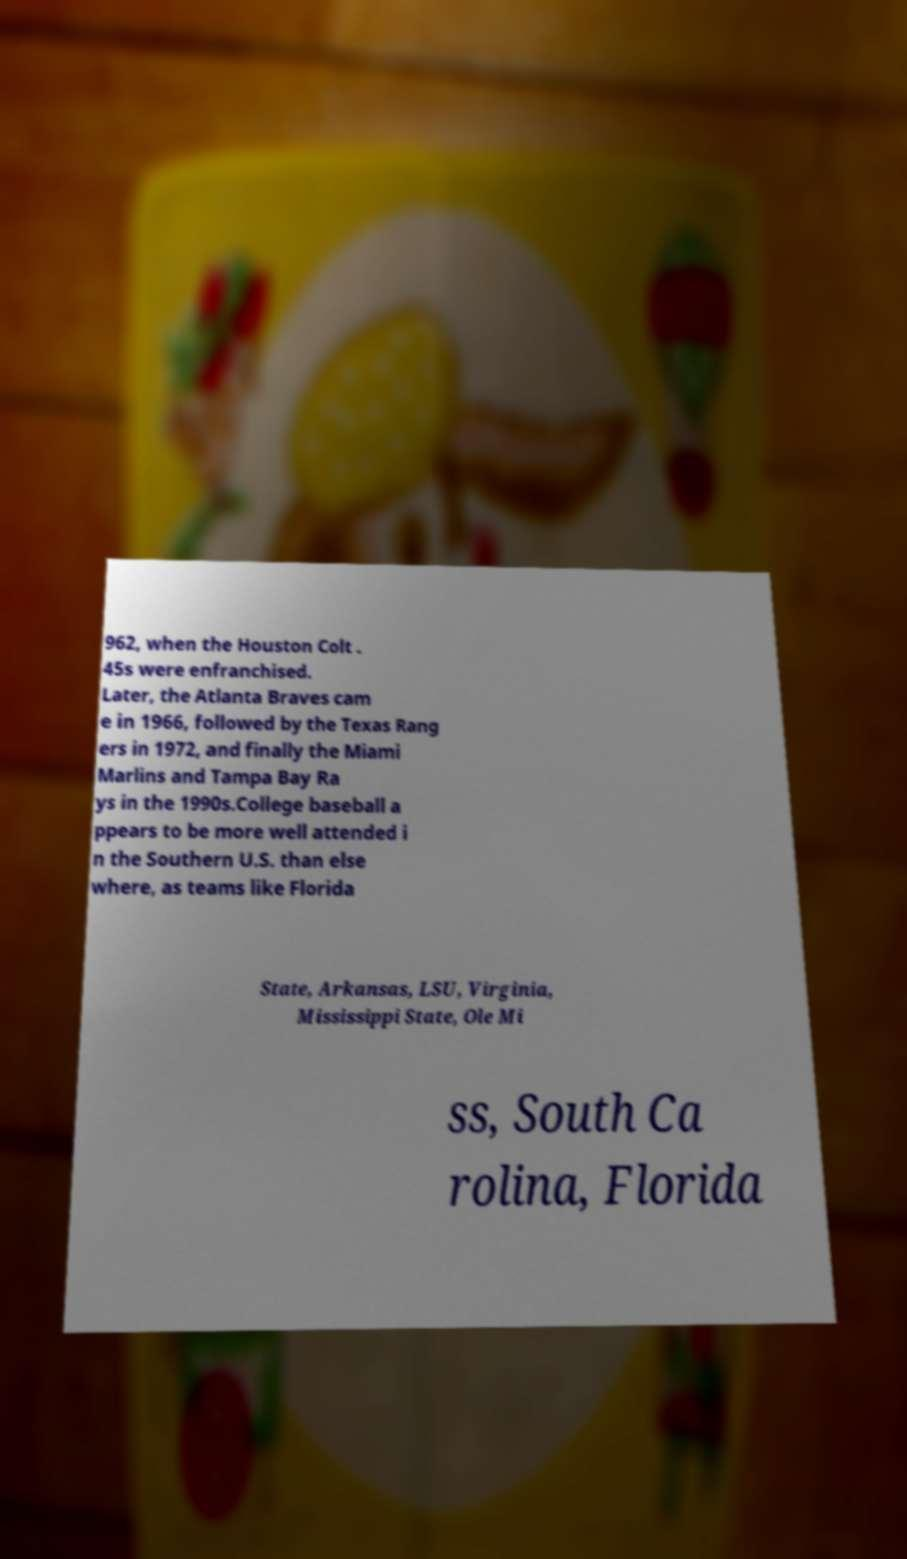For documentation purposes, I need the text within this image transcribed. Could you provide that? 962, when the Houston Colt . 45s were enfranchised. Later, the Atlanta Braves cam e in 1966, followed by the Texas Rang ers in 1972, and finally the Miami Marlins and Tampa Bay Ra ys in the 1990s.College baseball a ppears to be more well attended i n the Southern U.S. than else where, as teams like Florida State, Arkansas, LSU, Virginia, Mississippi State, Ole Mi ss, South Ca rolina, Florida 